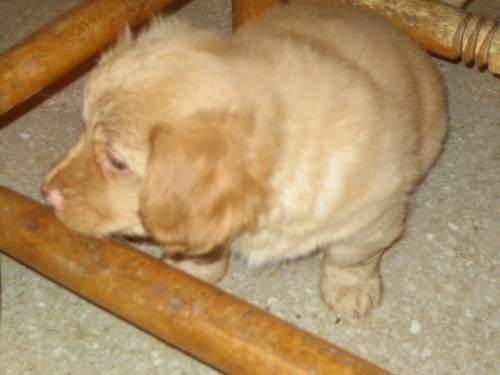What kind of environment is the puppy in? The puppy is in an indoor environment with a visible tiled floor. There seems to be a chair or a piece of furniture near the puppy, suggesting that it may be in a domestic setting like a home. Does the puppy look healthy and well-cared for? From this image, we can infer that the puppy appears to be in a safe environment. However, without clearer details or additional information about its overall behavior, diet, and activity level, it's difficult to fully assess the puppy's health and care. 